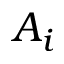<formula> <loc_0><loc_0><loc_500><loc_500>A _ { i }</formula> 